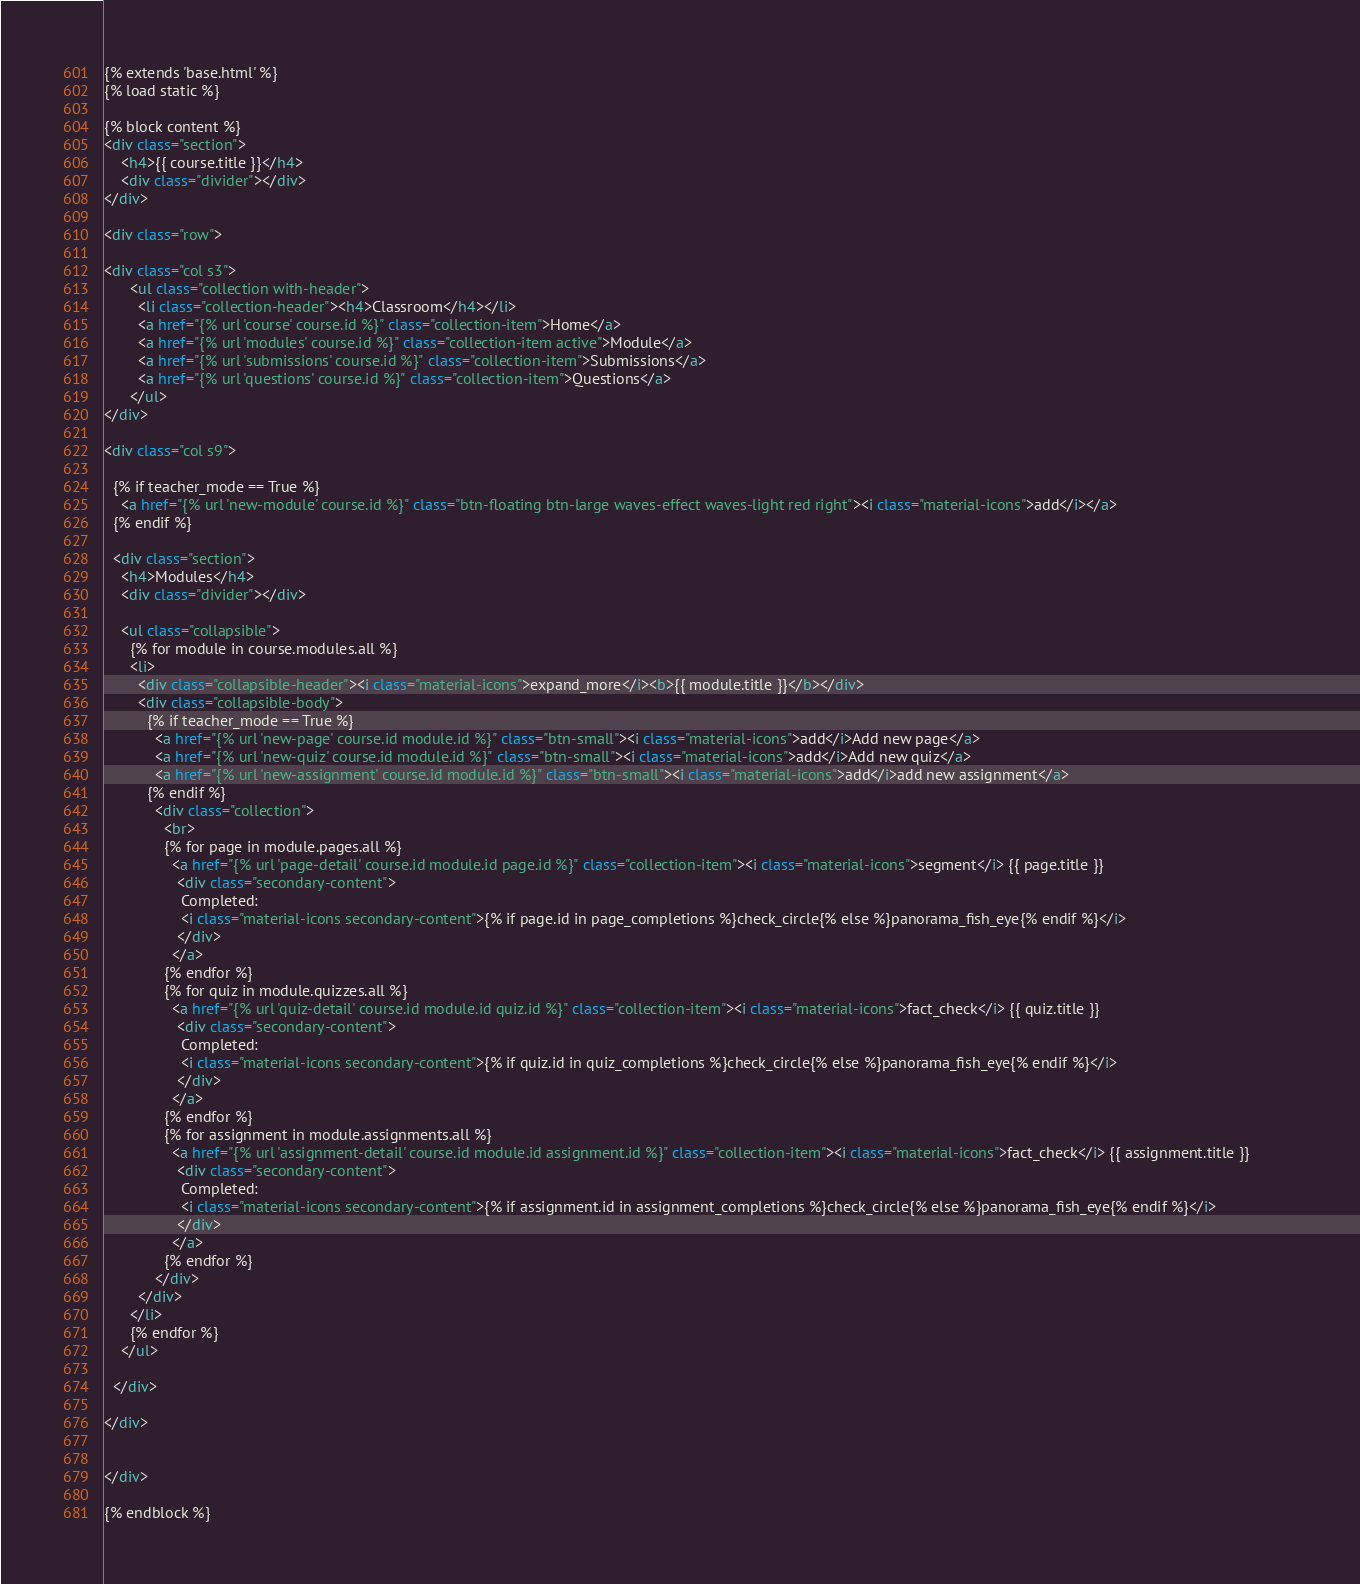Convert code to text. <code><loc_0><loc_0><loc_500><loc_500><_HTML_>{% extends 'base.html' %}
{% load static %}

{% block content %}
<div class="section">
	<h4>{{ course.title }}</h4>
	<div class="divider"></div>
</div>

<div class="row">

<div class="col s3">
      <ul class="collection with-header">
        <li class="collection-header"><h4>Classroom</h4></li>
        <a href="{% url 'course' course.id %}" class="collection-item">Home</a>
        <a href="{% url 'modules' course.id %}" class="collection-item active">Module</a>
        <a href="{% url 'submissions' course.id %}" class="collection-item">Submissions</a>
        <a href="{% url 'questions' course.id %}" class="collection-item">Questions</a>
      </ul>
</div>

<div class="col s9">

  {% if teacher_mode == True %}
    <a href="{% url 'new-module' course.id %}" class="btn-floating btn-large waves-effect waves-light red right"><i class="material-icons">add</i></a>
  {% endif %}

  <div class="section">
    <h4>Modules</h4>
    <div class="divider"></div> 

    <ul class="collapsible">
      {% for module in course.modules.all %}
      <li>
        <div class="collapsible-header"><i class="material-icons">expand_more</i><b>{{ module.title }}</b></div>
        <div class="collapsible-body">
          {% if teacher_mode == True %}
            <a href="{% url 'new-page' course.id module.id %}" class="btn-small"><i class="material-icons">add</i>Add new page</a>
            <a href="{% url 'new-quiz' course.id module.id %}" class="btn-small"><i class="material-icons">add</i>Add new quiz</a>
            <a href="{% url 'new-assignment' course.id module.id %}" class="btn-small"><i class="material-icons">add</i>add new assignment</a>
          {% endif %}
            <div class="collection">
              <br>
              {% for page in module.pages.all %}
                <a href="{% url 'page-detail' course.id module.id page.id %}" class="collection-item"><i class="material-icons">segment</i> {{ page.title }}
                 <div class="secondary-content">
                  Completed: 
                  <i class="material-icons secondary-content">{% if page.id in page_completions %}check_circle{% else %}panorama_fish_eye{% endif %}</i>                   
                 </div>
                </a>
              {% endfor %}
              {% for quiz in module.quizzes.all %}
                <a href="{% url 'quiz-detail' course.id module.id quiz.id %}" class="collection-item"><i class="material-icons">fact_check</i> {{ quiz.title }}
                 <div class="secondary-content">
                  Completed: 
                  <i class="material-icons secondary-content">{% if quiz.id in quiz_completions %}check_circle{% else %}panorama_fish_eye{% endif %}</i>                   
                 </div>
                </a>
              {% endfor %}
              {% for assignment in module.assignments.all %}
                <a href="{% url 'assignment-detail' course.id module.id assignment.id %}" class="collection-item"><i class="material-icons">fact_check</i> {{ assignment.title }}
                 <div class="secondary-content">
                  Completed: 
                  <i class="material-icons secondary-content">{% if assignment.id in assignment_completions %}check_circle{% else %}panorama_fish_eye{% endif %}</i>                   
                 </div>
                </a>
              {% endfor %}
            </div>
        </div>
      </li>
      {% endfor %}
    </ul>

  </div>
  
</div>


</div>

{% endblock %}</code> 